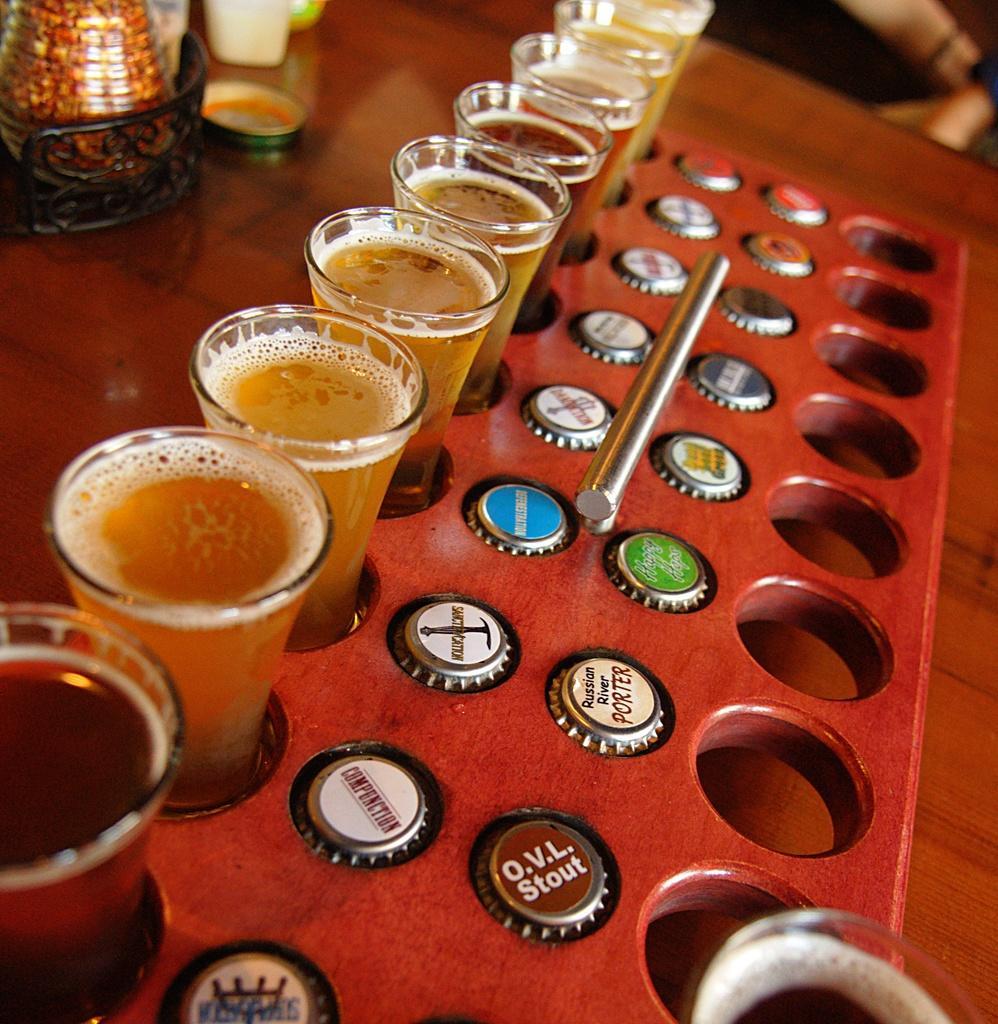In one or two sentences, can you explain what this image depicts? In this image I can see few glasses and bottle caps in the tray. I can see few objects and tray on the table. 